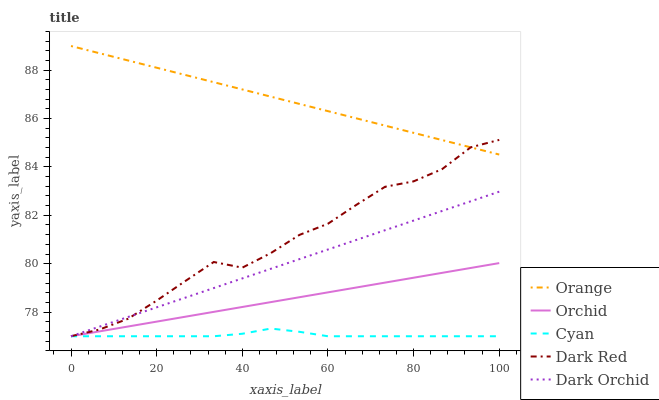Does Cyan have the minimum area under the curve?
Answer yes or no. Yes. Does Orange have the maximum area under the curve?
Answer yes or no. Yes. Does Dark Red have the minimum area under the curve?
Answer yes or no. No. Does Dark Red have the maximum area under the curve?
Answer yes or no. No. Is Dark Orchid the smoothest?
Answer yes or no. Yes. Is Dark Red the roughest?
Answer yes or no. Yes. Is Cyan the smoothest?
Answer yes or no. No. Is Cyan the roughest?
Answer yes or no. No. Does Cyan have the lowest value?
Answer yes or no. Yes. Does Orange have the highest value?
Answer yes or no. Yes. Does Dark Red have the highest value?
Answer yes or no. No. Is Orchid less than Orange?
Answer yes or no. Yes. Is Orange greater than Dark Orchid?
Answer yes or no. Yes. Does Orchid intersect Dark Orchid?
Answer yes or no. Yes. Is Orchid less than Dark Orchid?
Answer yes or no. No. Is Orchid greater than Dark Orchid?
Answer yes or no. No. Does Orchid intersect Orange?
Answer yes or no. No. 